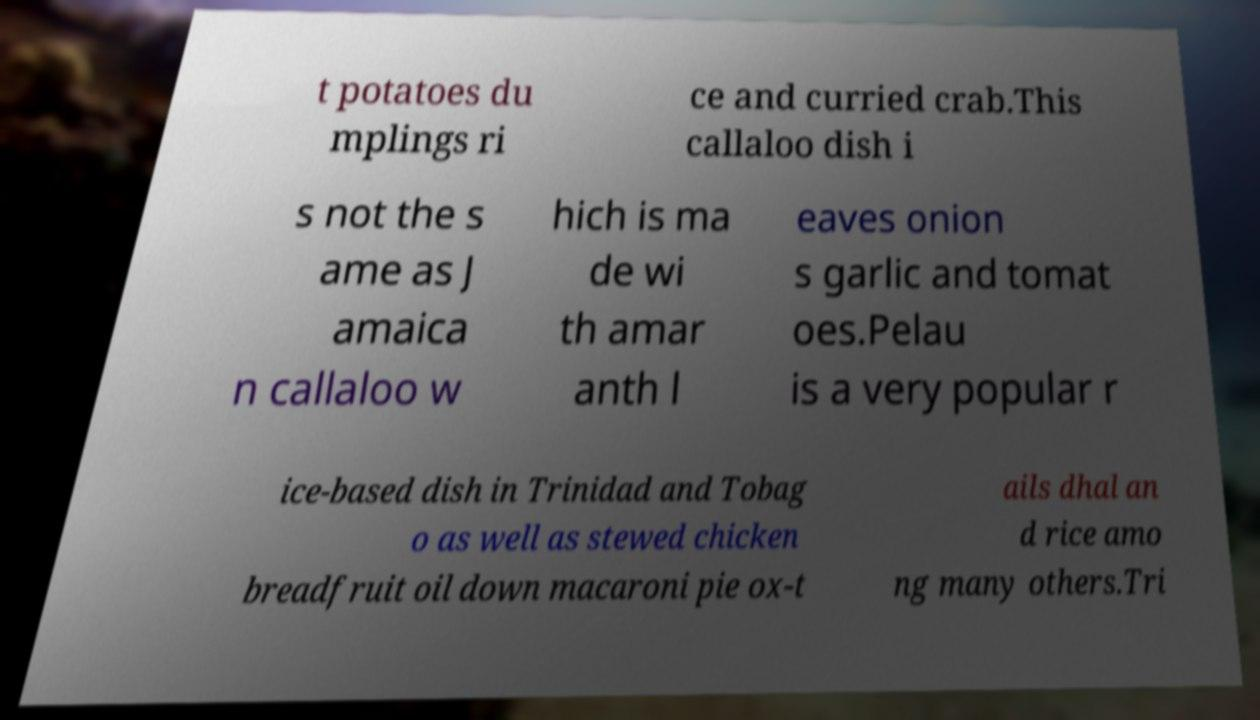Can you read and provide the text displayed in the image?This photo seems to have some interesting text. Can you extract and type it out for me? t potatoes du mplings ri ce and curried crab.This callaloo dish i s not the s ame as J amaica n callaloo w hich is ma de wi th amar anth l eaves onion s garlic and tomat oes.Pelau is a very popular r ice-based dish in Trinidad and Tobag o as well as stewed chicken breadfruit oil down macaroni pie ox-t ails dhal an d rice amo ng many others.Tri 